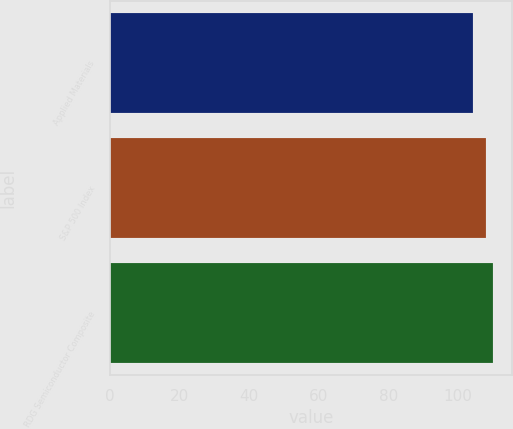<chart> <loc_0><loc_0><loc_500><loc_500><bar_chart><fcel>Applied Materials<fcel>S&P 500 Index<fcel>RDG Semiconductor Composite<nl><fcel>104.54<fcel>108.09<fcel>110.04<nl></chart> 